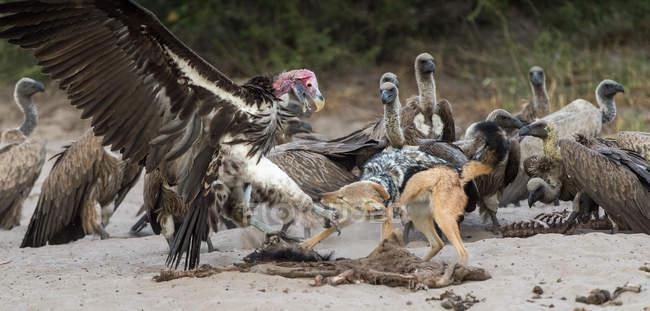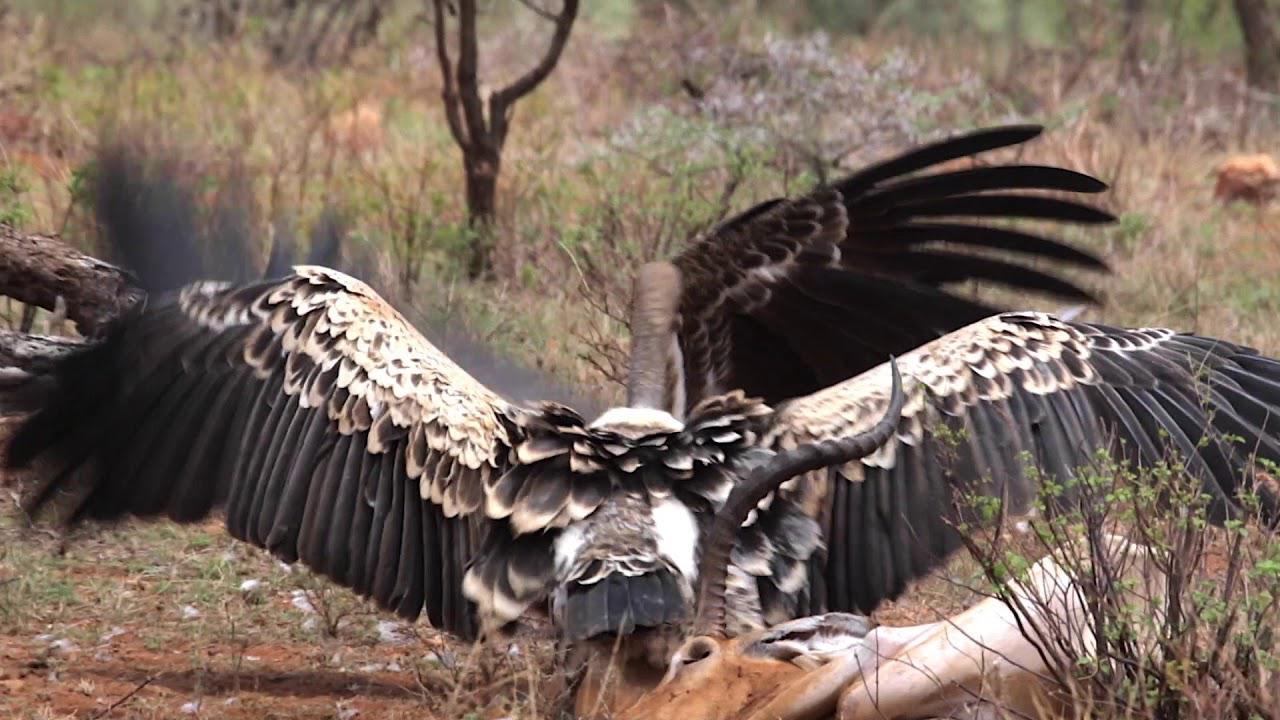The first image is the image on the left, the second image is the image on the right. Evaluate the accuracy of this statement regarding the images: "In at least one image there is a vulture white and black father flying into the ground with his beak open.". Is it true? Answer yes or no. Yes. 